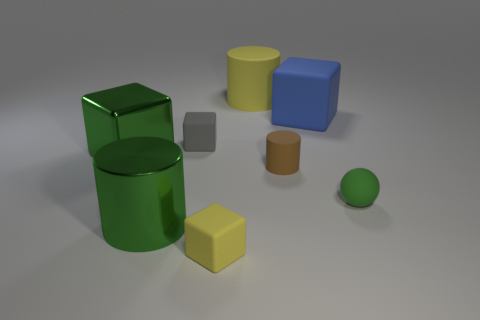There is a matte cube that is in front of the small cube behind the large green cylinder; what number of gray rubber things are to the left of it?
Your answer should be very brief. 1. There is a green object behind the tiny green matte ball; is its shape the same as the small matte object to the right of the small matte cylinder?
Your response must be concise. No. What number of things are small rubber blocks or rubber objects?
Your answer should be compact. 6. There is a block that is in front of the tiny rubber sphere that is in front of the green metal cube; what is it made of?
Your answer should be very brief. Rubber. Are there any rubber blocks of the same color as the tiny cylinder?
Your answer should be very brief. No. The other cube that is the same size as the yellow cube is what color?
Provide a short and direct response. Gray. What is the material of the big object that is behind the big cube that is behind the big block that is to the left of the tiny gray matte thing?
Provide a short and direct response. Rubber. There is a metal cylinder; does it have the same color as the large cylinder that is to the right of the small yellow rubber block?
Your response must be concise. No. How many things are small matte things that are left of the big rubber cylinder or large blocks right of the gray rubber cube?
Give a very brief answer. 3. What shape is the big green thing in front of the big cube to the left of the large yellow matte cylinder?
Provide a short and direct response. Cylinder. 